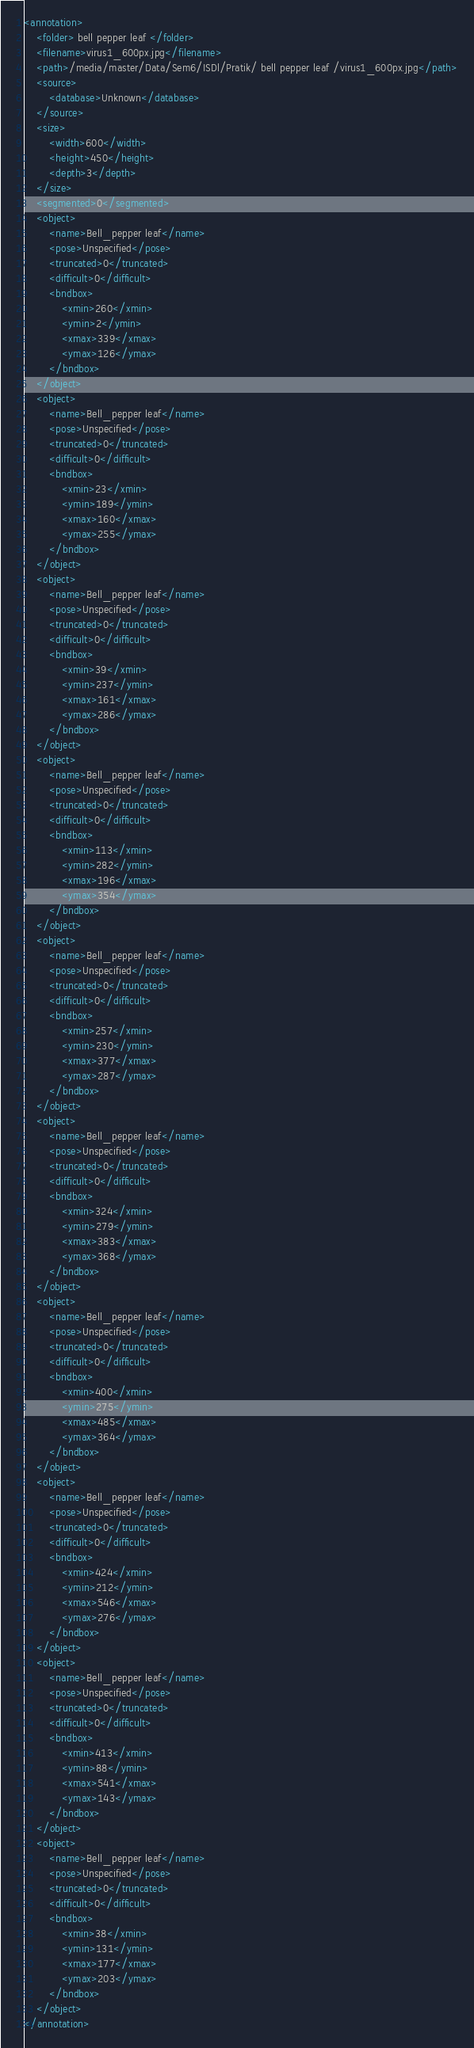Convert code to text. <code><loc_0><loc_0><loc_500><loc_500><_XML_><annotation>
	<folder> bell pepper leaf </folder>
	<filename>virus1_600px.jpg</filename>
	<path>/media/master/Data/Sem6/ISDl/Pratik/ bell pepper leaf /virus1_600px.jpg</path>
	<source>
		<database>Unknown</database>
	</source>
	<size>
		<width>600</width>
		<height>450</height>
		<depth>3</depth>
	</size>
	<segmented>0</segmented>
	<object>
		<name>Bell_pepper leaf</name>
		<pose>Unspecified</pose>
		<truncated>0</truncated>
		<difficult>0</difficult>
		<bndbox>
			<xmin>260</xmin>
			<ymin>2</ymin>
			<xmax>339</xmax>
			<ymax>126</ymax>
		</bndbox>
	</object>
	<object>
		<name>Bell_pepper leaf</name>
		<pose>Unspecified</pose>
		<truncated>0</truncated>
		<difficult>0</difficult>
		<bndbox>
			<xmin>23</xmin>
			<ymin>189</ymin>
			<xmax>160</xmax>
			<ymax>255</ymax>
		</bndbox>
	</object>
	<object>
		<name>Bell_pepper leaf</name>
		<pose>Unspecified</pose>
		<truncated>0</truncated>
		<difficult>0</difficult>
		<bndbox>
			<xmin>39</xmin>
			<ymin>237</ymin>
			<xmax>161</xmax>
			<ymax>286</ymax>
		</bndbox>
	</object>
	<object>
		<name>Bell_pepper leaf</name>
		<pose>Unspecified</pose>
		<truncated>0</truncated>
		<difficult>0</difficult>
		<bndbox>
			<xmin>113</xmin>
			<ymin>282</ymin>
			<xmax>196</xmax>
			<ymax>354</ymax>
		</bndbox>
	</object>
	<object>
		<name>Bell_pepper leaf</name>
		<pose>Unspecified</pose>
		<truncated>0</truncated>
		<difficult>0</difficult>
		<bndbox>
			<xmin>257</xmin>
			<ymin>230</ymin>
			<xmax>377</xmax>
			<ymax>287</ymax>
		</bndbox>
	</object>
	<object>
		<name>Bell_pepper leaf</name>
		<pose>Unspecified</pose>
		<truncated>0</truncated>
		<difficult>0</difficult>
		<bndbox>
			<xmin>324</xmin>
			<ymin>279</ymin>
			<xmax>383</xmax>
			<ymax>368</ymax>
		</bndbox>
	</object>
	<object>
		<name>Bell_pepper leaf</name>
		<pose>Unspecified</pose>
		<truncated>0</truncated>
		<difficult>0</difficult>
		<bndbox>
			<xmin>400</xmin>
			<ymin>275</ymin>
			<xmax>485</xmax>
			<ymax>364</ymax>
		</bndbox>
	</object>
	<object>
		<name>Bell_pepper leaf</name>
		<pose>Unspecified</pose>
		<truncated>0</truncated>
		<difficult>0</difficult>
		<bndbox>
			<xmin>424</xmin>
			<ymin>212</ymin>
			<xmax>546</xmax>
			<ymax>276</ymax>
		</bndbox>
	</object>
	<object>
		<name>Bell_pepper leaf</name>
		<pose>Unspecified</pose>
		<truncated>0</truncated>
		<difficult>0</difficult>
		<bndbox>
			<xmin>413</xmin>
			<ymin>88</ymin>
			<xmax>541</xmax>
			<ymax>143</ymax>
		</bndbox>
	</object>
	<object>
		<name>Bell_pepper leaf</name>
		<pose>Unspecified</pose>
		<truncated>0</truncated>
		<difficult>0</difficult>
		<bndbox>
			<xmin>38</xmin>
			<ymin>131</ymin>
			<xmax>177</xmax>
			<ymax>203</ymax>
		</bndbox>
	</object>
</annotation>
</code> 